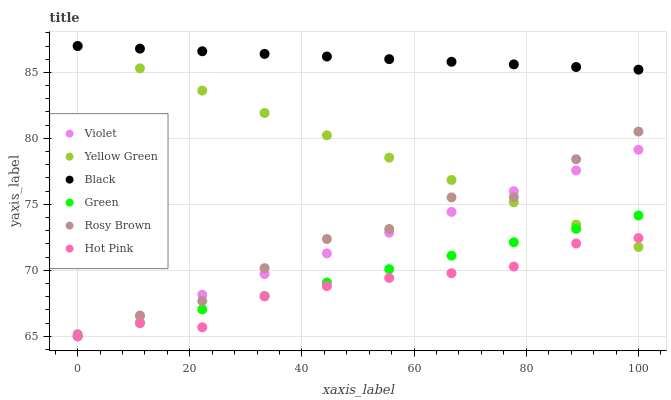Does Hot Pink have the minimum area under the curve?
Answer yes or no. Yes. Does Black have the maximum area under the curve?
Answer yes or no. Yes. Does Yellow Green have the minimum area under the curve?
Answer yes or no. No. Does Yellow Green have the maximum area under the curve?
Answer yes or no. No. Is Green the smoothest?
Answer yes or no. Yes. Is Rosy Brown the roughest?
Answer yes or no. Yes. Is Yellow Green the smoothest?
Answer yes or no. No. Is Yellow Green the roughest?
Answer yes or no. No. Does Hot Pink have the lowest value?
Answer yes or no. Yes. Does Yellow Green have the lowest value?
Answer yes or no. No. Does Black have the highest value?
Answer yes or no. Yes. Does Hot Pink have the highest value?
Answer yes or no. No. Is Violet less than Black?
Answer yes or no. Yes. Is Rosy Brown greater than Green?
Answer yes or no. Yes. Does Green intersect Yellow Green?
Answer yes or no. Yes. Is Green less than Yellow Green?
Answer yes or no. No. Is Green greater than Yellow Green?
Answer yes or no. No. Does Violet intersect Black?
Answer yes or no. No. 